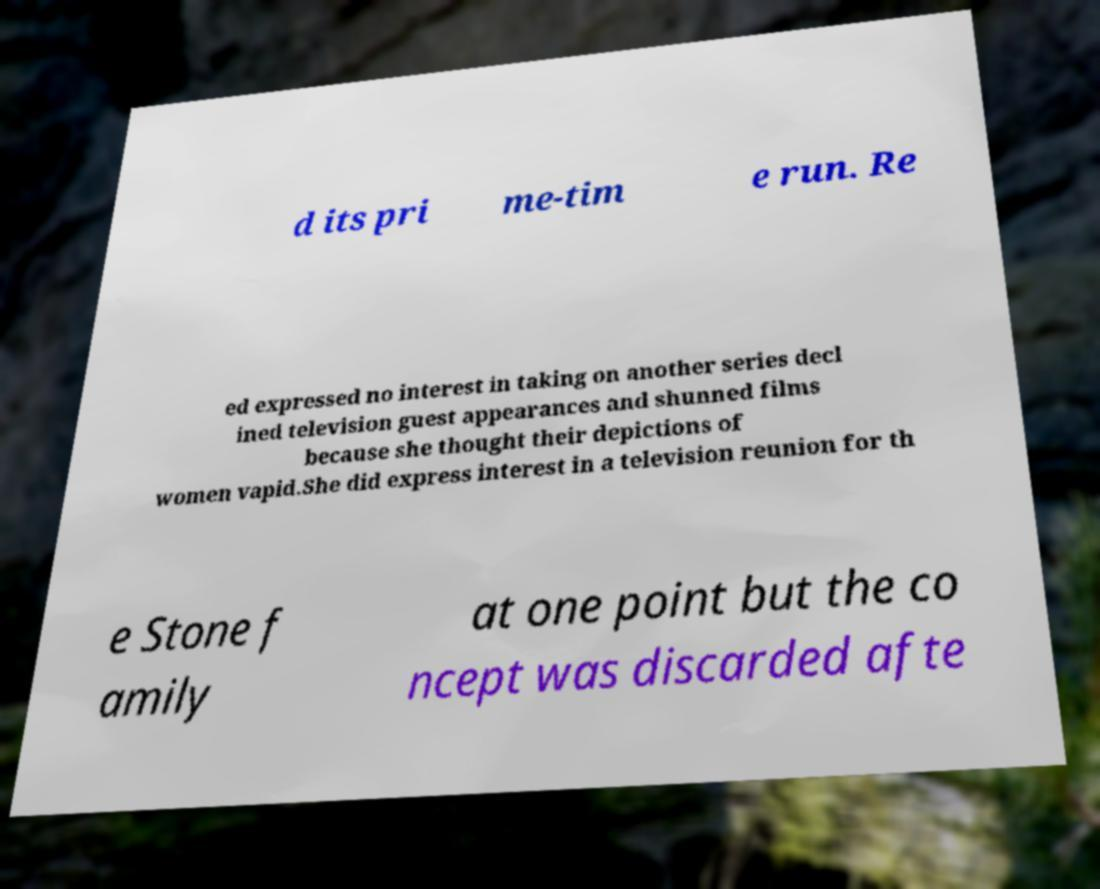Could you extract and type out the text from this image? d its pri me-tim e run. Re ed expressed no interest in taking on another series decl ined television guest appearances and shunned films because she thought their depictions of women vapid.She did express interest in a television reunion for th e Stone f amily at one point but the co ncept was discarded afte 